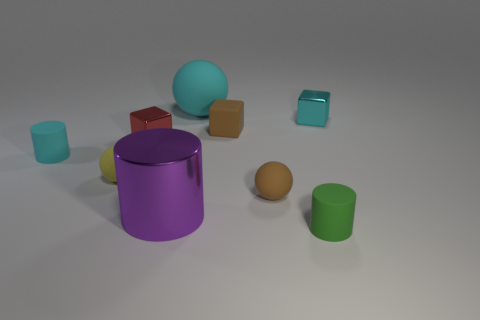How many other objects are the same shape as the small yellow object?
Offer a terse response. 2. How many yellow rubber balls are right of the big cyan object?
Give a very brief answer. 0. Is the number of tiny brown objects behind the small green matte cylinder less than the number of small matte blocks that are left of the shiny cylinder?
Ensure brevity in your answer.  No. The big thing that is in front of the small cyan object to the right of the small brown rubber object that is in front of the yellow object is what shape?
Ensure brevity in your answer.  Cylinder. What shape is the tiny rubber thing that is both behind the yellow matte ball and to the right of the cyan rubber sphere?
Your answer should be compact. Cube. Is there a tiny brown cylinder that has the same material as the small yellow ball?
Make the answer very short. No. There is a block that is the same color as the large sphere; what is its size?
Provide a short and direct response. Small. What color is the small rubber cylinder on the right side of the tiny cyan matte cylinder?
Give a very brief answer. Green. There is a green matte object; does it have the same shape as the object that is to the left of the tiny yellow object?
Provide a short and direct response. Yes. Are there any cylinders of the same color as the matte cube?
Keep it short and to the point. No. 